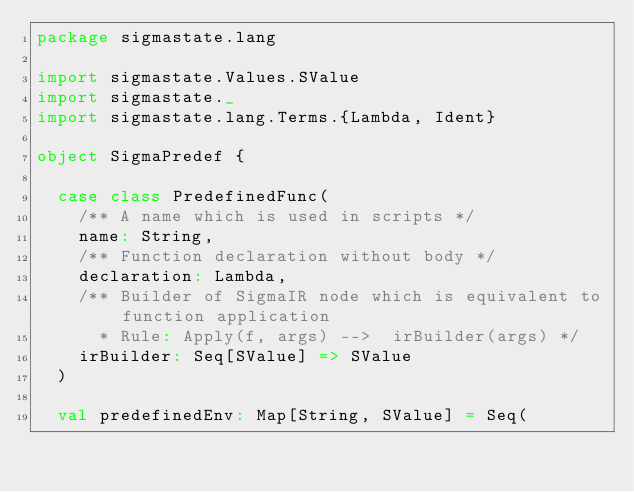<code> <loc_0><loc_0><loc_500><loc_500><_Scala_>package sigmastate.lang

import sigmastate.Values.SValue
import sigmastate._
import sigmastate.lang.Terms.{Lambda, Ident}

object SigmaPredef {

  case class PredefinedFunc(
    /** A name which is used in scripts */
    name: String,
    /** Function declaration without body */
    declaration: Lambda,
    /** Builder of SigmaIR node which is equivalent to function application
      * Rule: Apply(f, args) -->  irBuilder(args) */
    irBuilder: Seq[SValue] => SValue
  )
  
  val predefinedEnv: Map[String, SValue] = Seq(</code> 